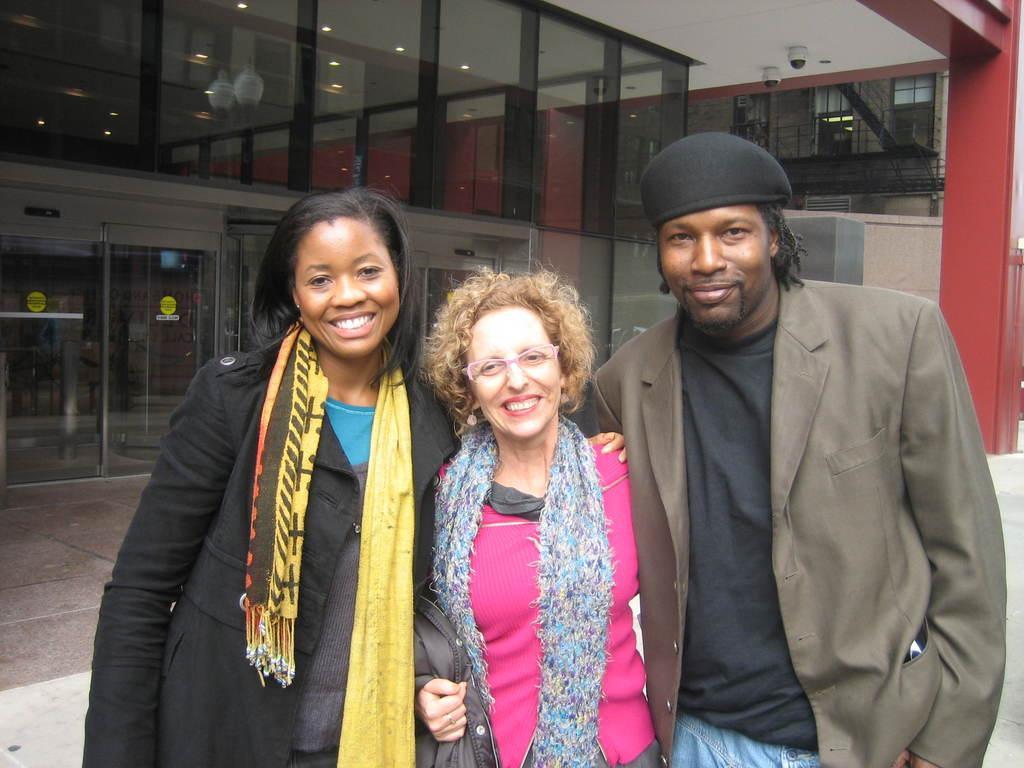Please provide a concise description of this image. In this image I see 2 women and a man and I see that 3 of them are smiling and I see that they're standing. In the background I see buildings and through the glasses I see the lights and I see the path. 